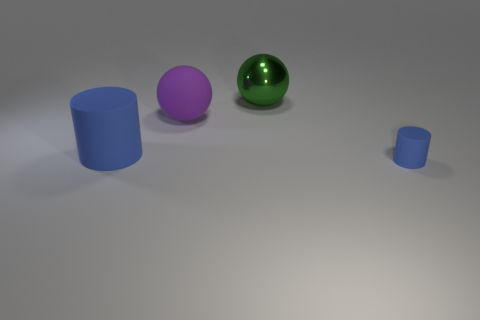Do the big rubber thing in front of the matte sphere and the small rubber thing have the same color?
Your answer should be very brief. Yes. There is a rubber cylinder that is the same color as the small rubber thing; what is its size?
Ensure brevity in your answer.  Large. There is a blue thing that is made of the same material as the big cylinder; what size is it?
Your response must be concise. Small. What is the shape of the blue thing that is right of the large blue rubber cylinder?
Provide a short and direct response. Cylinder. What is the size of the other blue thing that is the same shape as the big blue thing?
Ensure brevity in your answer.  Small. How many green spheres are on the right side of the cylinder that is in front of the big blue cylinder that is behind the small cylinder?
Your response must be concise. 0. Are there an equal number of tiny rubber things that are behind the big rubber cylinder and tiny brown cylinders?
Ensure brevity in your answer.  Yes. What number of cylinders are either tiny matte things or tiny green things?
Ensure brevity in your answer.  1. Does the small cylinder have the same color as the large matte cylinder?
Provide a short and direct response. Yes. Is the number of purple rubber objects that are in front of the large blue rubber cylinder the same as the number of objects behind the tiny blue cylinder?
Offer a very short reply. No. 